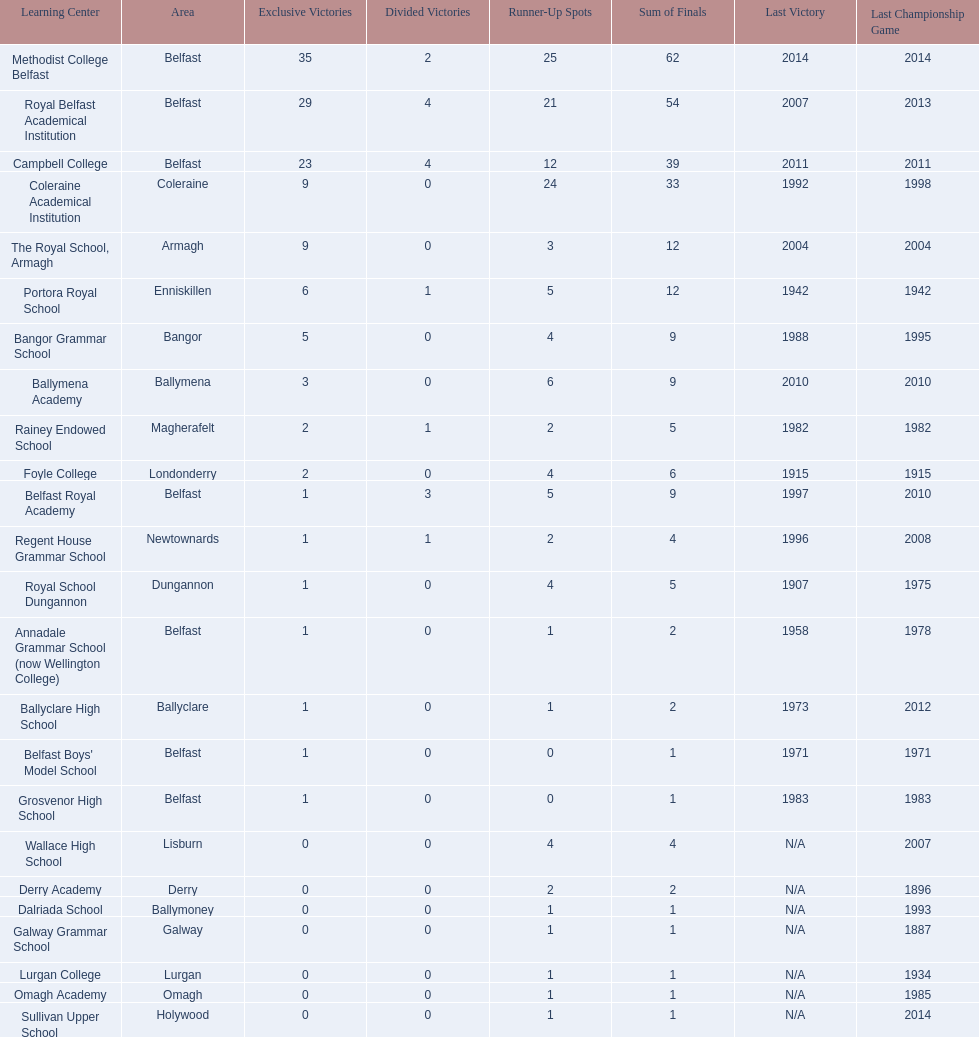What was the last year that the regent house grammar school won a title? 1996. Would you mind parsing the complete table? {'header': ['Learning Center', 'Area', 'Exclusive Victories', 'Divided Victories', 'Runner-Up Spots', 'Sum of Finals', 'Last Victory', 'Last Championship Game'], 'rows': [['Methodist College Belfast', 'Belfast', '35', '2', '25', '62', '2014', '2014'], ['Royal Belfast Academical Institution', 'Belfast', '29', '4', '21', '54', '2007', '2013'], ['Campbell College', 'Belfast', '23', '4', '12', '39', '2011', '2011'], ['Coleraine Academical Institution', 'Coleraine', '9', '0', '24', '33', '1992', '1998'], ['The Royal School, Armagh', 'Armagh', '9', '0', '3', '12', '2004', '2004'], ['Portora Royal School', 'Enniskillen', '6', '1', '5', '12', '1942', '1942'], ['Bangor Grammar School', 'Bangor', '5', '0', '4', '9', '1988', '1995'], ['Ballymena Academy', 'Ballymena', '3', '0', '6', '9', '2010', '2010'], ['Rainey Endowed School', 'Magherafelt', '2', '1', '2', '5', '1982', '1982'], ['Foyle College', 'Londonderry', '2', '0', '4', '6', '1915', '1915'], ['Belfast Royal Academy', 'Belfast', '1', '3', '5', '9', '1997', '2010'], ['Regent House Grammar School', 'Newtownards', '1', '1', '2', '4', '1996', '2008'], ['Royal School Dungannon', 'Dungannon', '1', '0', '4', '5', '1907', '1975'], ['Annadale Grammar School (now Wellington College)', 'Belfast', '1', '0', '1', '2', '1958', '1978'], ['Ballyclare High School', 'Ballyclare', '1', '0', '1', '2', '1973', '2012'], ["Belfast Boys' Model School", 'Belfast', '1', '0', '0', '1', '1971', '1971'], ['Grosvenor High School', 'Belfast', '1', '0', '0', '1', '1983', '1983'], ['Wallace High School', 'Lisburn', '0', '0', '4', '4', 'N/A', '2007'], ['Derry Academy', 'Derry', '0', '0', '2', '2', 'N/A', '1896'], ['Dalriada School', 'Ballymoney', '0', '0', '1', '1', 'N/A', '1993'], ['Galway Grammar School', 'Galway', '0', '0', '1', '1', 'N/A', '1887'], ['Lurgan College', 'Lurgan', '0', '0', '1', '1', 'N/A', '1934'], ['Omagh Academy', 'Omagh', '0', '0', '1', '1', 'N/A', '1985'], ['Sullivan Upper School', 'Holywood', '0', '0', '1', '1', 'N/A', '2014']]} 